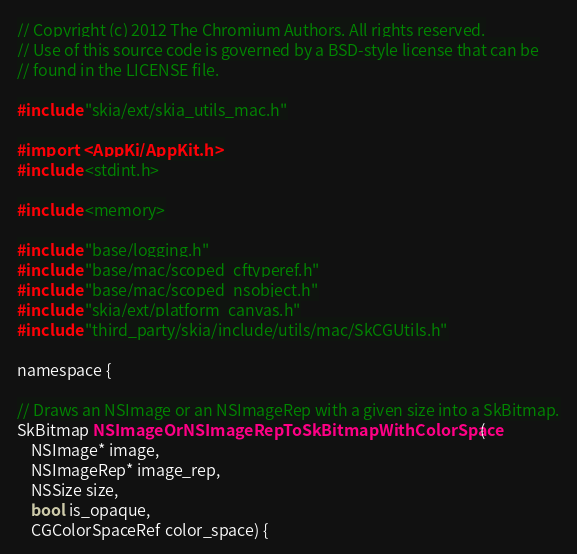Convert code to text. <code><loc_0><loc_0><loc_500><loc_500><_ObjectiveC_>// Copyright (c) 2012 The Chromium Authors. All rights reserved.
// Use of this source code is governed by a BSD-style license that can be
// found in the LICENSE file.

#include "skia/ext/skia_utils_mac.h"

#import <AppKit/AppKit.h>
#include <stdint.h>

#include <memory>

#include "base/logging.h"
#include "base/mac/scoped_cftyperef.h"
#include "base/mac/scoped_nsobject.h"
#include "skia/ext/platform_canvas.h"
#include "third_party/skia/include/utils/mac/SkCGUtils.h"

namespace {

// Draws an NSImage or an NSImageRep with a given size into a SkBitmap.
SkBitmap NSImageOrNSImageRepToSkBitmapWithColorSpace(
    NSImage* image,
    NSImageRep* image_rep,
    NSSize size,
    bool is_opaque,
    CGColorSpaceRef color_space) {</code> 